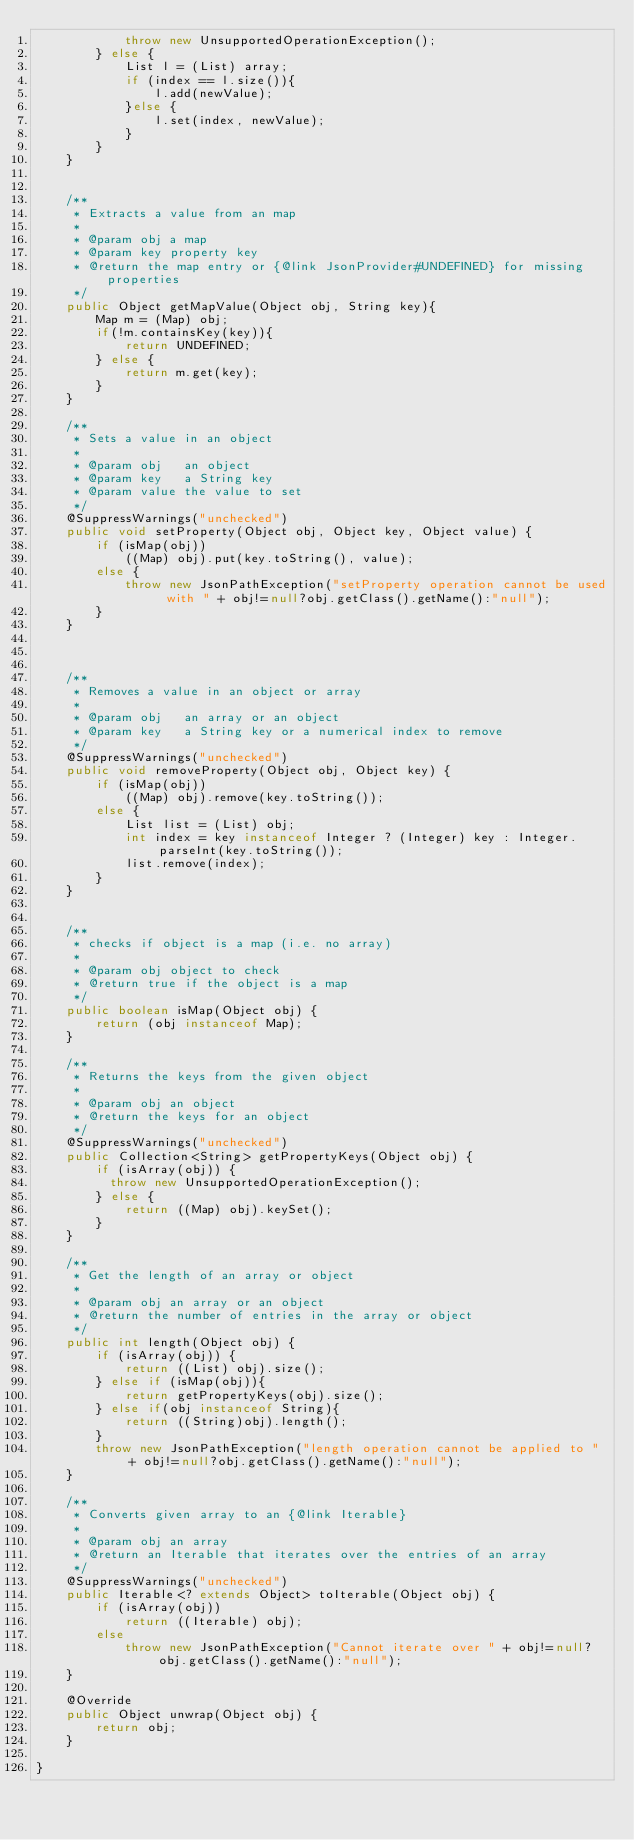<code> <loc_0><loc_0><loc_500><loc_500><_Java_>            throw new UnsupportedOperationException();
        } else {
            List l = (List) array;
            if (index == l.size()){
                l.add(newValue);
            }else {
                l.set(index, newValue);
            }
        }
    }


    /**
     * Extracts a value from an map
     *
     * @param obj a map
     * @param key property key
     * @return the map entry or {@link JsonProvider#UNDEFINED} for missing properties
     */
    public Object getMapValue(Object obj, String key){
        Map m = (Map) obj;
        if(!m.containsKey(key)){
            return UNDEFINED;
        } else {
            return m.get(key);
        }
    }

    /**
     * Sets a value in an object
     *
     * @param obj   an object
     * @param key   a String key
     * @param value the value to set
     */
    @SuppressWarnings("unchecked")
    public void setProperty(Object obj, Object key, Object value) {
        if (isMap(obj))
            ((Map) obj).put(key.toString(), value);
        else {
            throw new JsonPathException("setProperty operation cannot be used with " + obj!=null?obj.getClass().getName():"null");
        }
    }



    /**
     * Removes a value in an object or array
     *
     * @param obj   an array or an object
     * @param key   a String key or a numerical index to remove
     */
    @SuppressWarnings("unchecked")
    public void removeProperty(Object obj, Object key) {
        if (isMap(obj))
            ((Map) obj).remove(key.toString());
        else {
            List list = (List) obj;
            int index = key instanceof Integer ? (Integer) key : Integer.parseInt(key.toString());
            list.remove(index);
        }
    }


    /**
     * checks if object is a map (i.e. no array)
     *
     * @param obj object to check
     * @return true if the object is a map
     */
    public boolean isMap(Object obj) {
        return (obj instanceof Map);
    }

    /**
     * Returns the keys from the given object
     *
     * @param obj an object
     * @return the keys for an object
     */
    @SuppressWarnings("unchecked")
    public Collection<String> getPropertyKeys(Object obj) {
        if (isArray(obj)) {
          throw new UnsupportedOperationException();
        } else {
            return ((Map) obj).keySet();
        }
    }

    /**
     * Get the length of an array or object
     *
     * @param obj an array or an object
     * @return the number of entries in the array or object
     */
    public int length(Object obj) {
        if (isArray(obj)) {
            return ((List) obj).size();
        } else if (isMap(obj)){
            return getPropertyKeys(obj).size();
        } else if(obj instanceof String){
            return ((String)obj).length();
        }
        throw new JsonPathException("length operation cannot be applied to " + obj!=null?obj.getClass().getName():"null");
    }

    /**
     * Converts given array to an {@link Iterable}
     *
     * @param obj an array
     * @return an Iterable that iterates over the entries of an array
     */
    @SuppressWarnings("unchecked")
    public Iterable<? extends Object> toIterable(Object obj) {
        if (isArray(obj))
            return ((Iterable) obj);
        else
            throw new JsonPathException("Cannot iterate over " + obj!=null?obj.getClass().getName():"null");
    }

    @Override
    public Object unwrap(Object obj) {
        return obj;
    }

}
</code> 